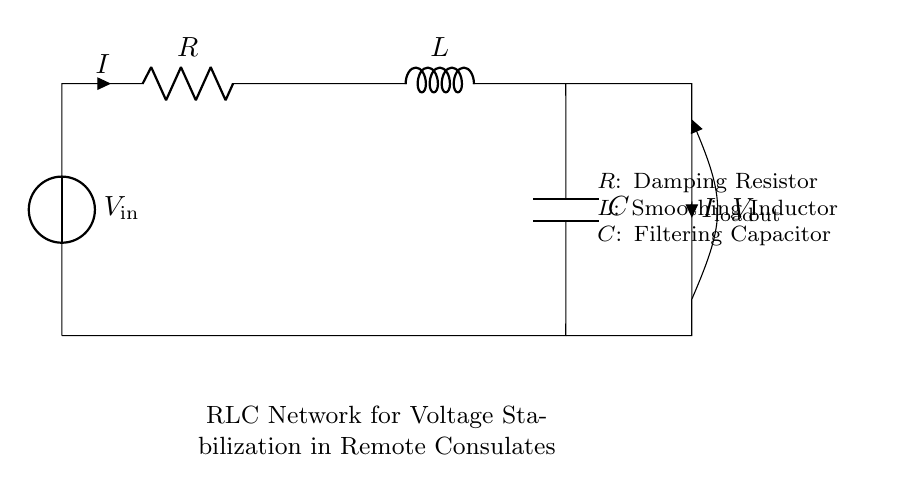What is the input voltage of the circuit? The input voltage is represented by the voltage source labeled as "V_in" in the diagram, which indicates the voltage supplied to the circuit.
Answer: V_in What does the component labeled R represent? The component labeled "R" is the damping resistor, which is used to reduce oscillations and stabilize the circuit's performance.
Answer: Damping Resistor What is the purpose of the inductor in this circuit? The inductor labeled "L" functions as a smoothing inductor, which helps to maintain a steady flow of current by resisting changes in current and smoothing out fluctuations.
Answer: Smoothing Inductor What is the role of the capacitor in this network? The capacitor labeled "C" serves as a filtering capacitor, which is used to filter out voltage spikes and maintain stable voltage across the load.
Answer: Filtering Capacitor How many components are there in the RLC network? The diagram consists of three main components: R, L, and C, indicating a basic RLC network configuration.
Answer: Three What is the relationship between the output voltage and the load current? The output voltage, labeled as "V_out," is affected by the load current "I_load," suggesting that as the load current changes, the output voltage is influenced by the values of R, L, and C in the circuit.
Answer: Influenced What type of circuit is represented here? The circuit represents a resistor-inductor-capacitor (RLC) network, commonly used for voltage stabilization and filtering in power conditioning applications.
Answer: RLC Network 